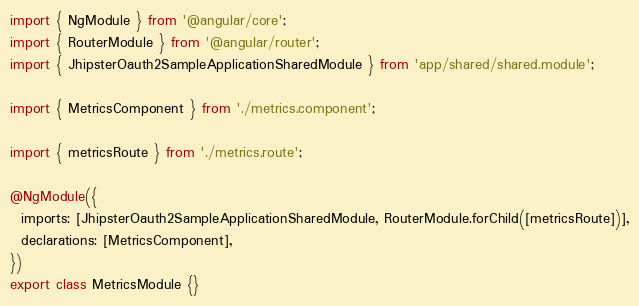<code> <loc_0><loc_0><loc_500><loc_500><_TypeScript_>import { NgModule } from '@angular/core';
import { RouterModule } from '@angular/router';
import { JhipsterOauth2SampleApplicationSharedModule } from 'app/shared/shared.module';

import { MetricsComponent } from './metrics.component';

import { metricsRoute } from './metrics.route';

@NgModule({
  imports: [JhipsterOauth2SampleApplicationSharedModule, RouterModule.forChild([metricsRoute])],
  declarations: [MetricsComponent],
})
export class MetricsModule {}
</code> 